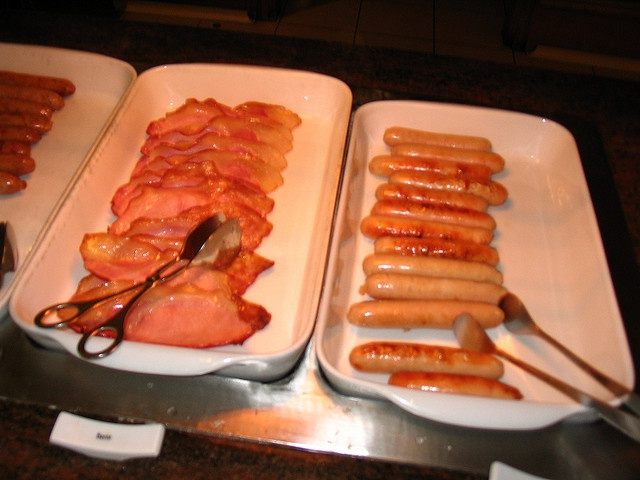Describe the objects in this image and their specific colors. I can see bowl in black, red, salmon, and tan tones, bowl in black, tan, and red tones, hot dog in black, salmon, maroon, and red tones, bowl in black, tan, salmon, maroon, and brown tones, and hot dog in black, red, brown, and salmon tones in this image. 